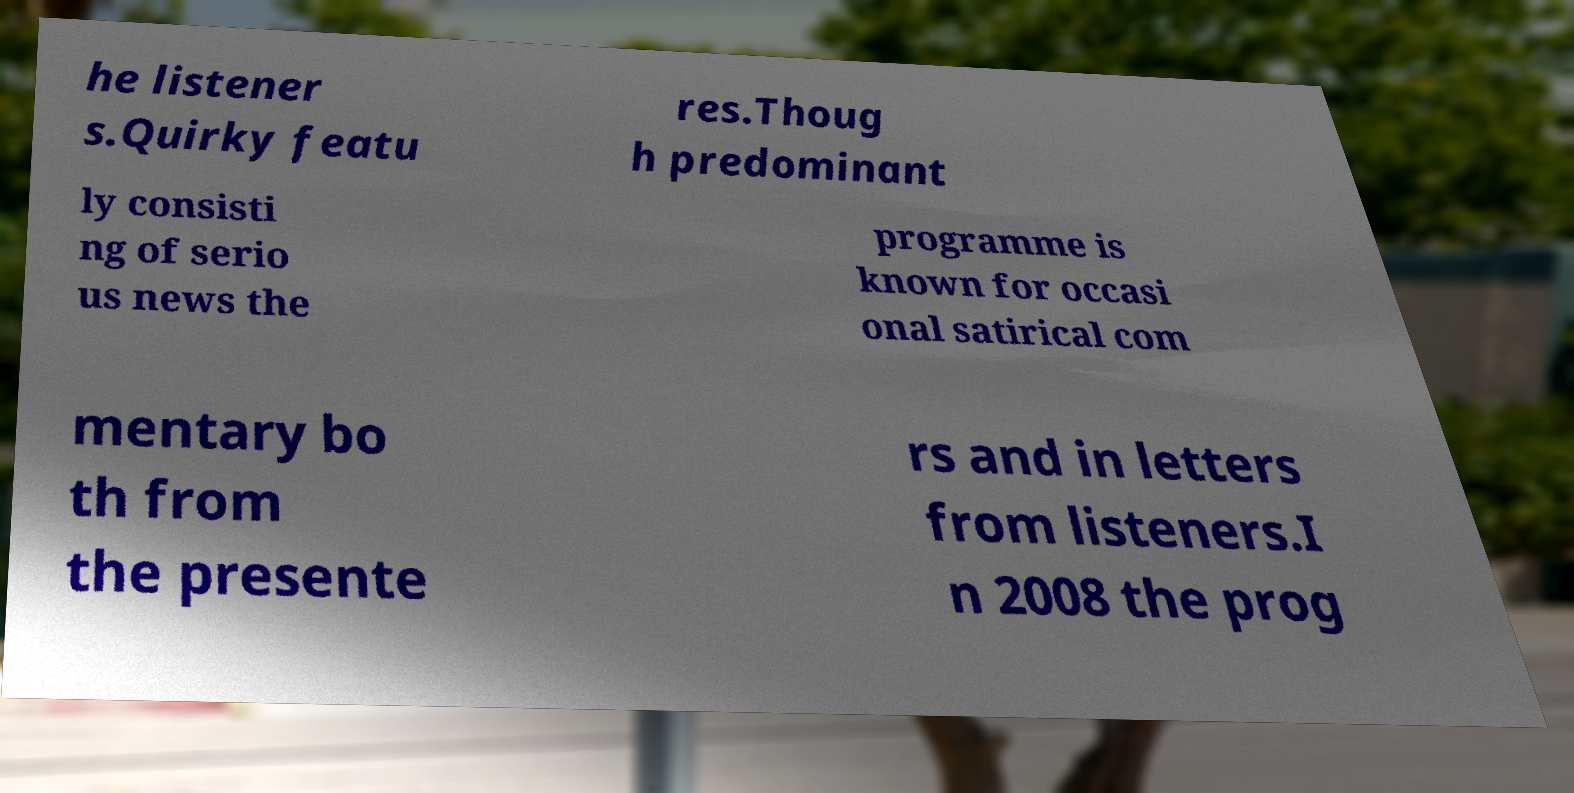I need the written content from this picture converted into text. Can you do that? he listener s.Quirky featu res.Thoug h predominant ly consisti ng of serio us news the programme is known for occasi onal satirical com mentary bo th from the presente rs and in letters from listeners.I n 2008 the prog 